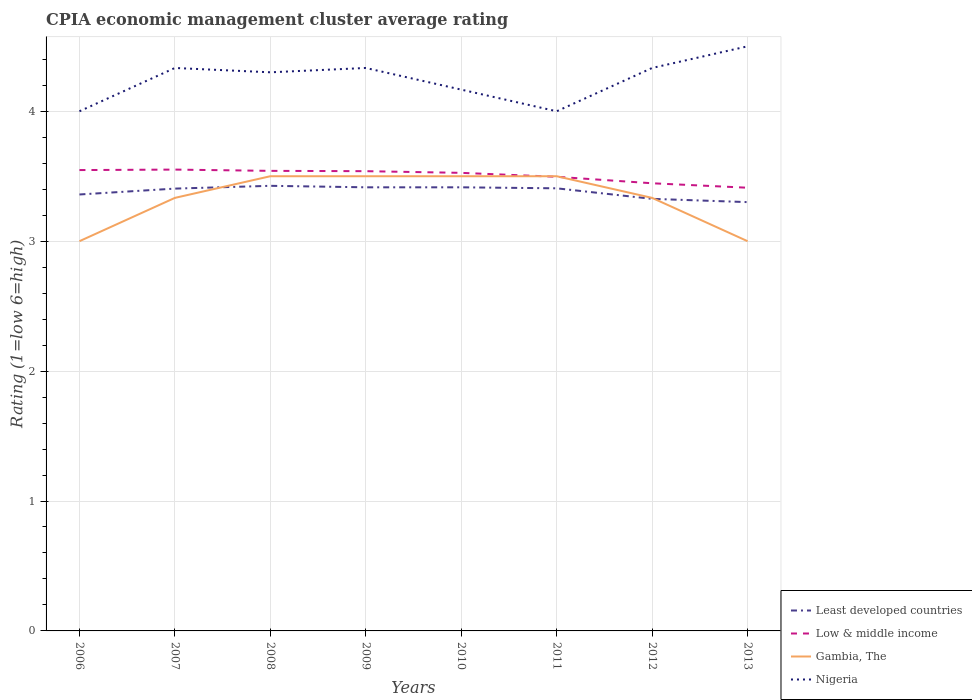How many different coloured lines are there?
Give a very brief answer. 4. Does the line corresponding to Low & middle income intersect with the line corresponding to Least developed countries?
Provide a succinct answer. No. In which year was the CPIA rating in Gambia, The maximum?
Make the answer very short. 2006. What is the total CPIA rating in Gambia, The in the graph?
Your response must be concise. -0.17. What is the difference between the highest and the second highest CPIA rating in Low & middle income?
Make the answer very short. 0.14. What is the difference between the highest and the lowest CPIA rating in Nigeria?
Offer a terse response. 5. Is the CPIA rating in Gambia, The strictly greater than the CPIA rating in Low & middle income over the years?
Your answer should be very brief. No. How many lines are there?
Make the answer very short. 4. What is the difference between two consecutive major ticks on the Y-axis?
Offer a very short reply. 1. How are the legend labels stacked?
Offer a very short reply. Vertical. What is the title of the graph?
Offer a terse response. CPIA economic management cluster average rating. What is the label or title of the Y-axis?
Your answer should be compact. Rating (1=low 6=high). What is the Rating (1=low 6=high) of Least developed countries in 2006?
Make the answer very short. 3.36. What is the Rating (1=low 6=high) of Low & middle income in 2006?
Your answer should be very brief. 3.55. What is the Rating (1=low 6=high) of Least developed countries in 2007?
Keep it short and to the point. 3.4. What is the Rating (1=low 6=high) of Low & middle income in 2007?
Offer a very short reply. 3.55. What is the Rating (1=low 6=high) in Gambia, The in 2007?
Offer a very short reply. 3.33. What is the Rating (1=low 6=high) of Nigeria in 2007?
Ensure brevity in your answer.  4.33. What is the Rating (1=low 6=high) of Least developed countries in 2008?
Provide a succinct answer. 3.43. What is the Rating (1=low 6=high) of Low & middle income in 2008?
Your answer should be compact. 3.54. What is the Rating (1=low 6=high) in Least developed countries in 2009?
Offer a terse response. 3.41. What is the Rating (1=low 6=high) in Low & middle income in 2009?
Ensure brevity in your answer.  3.54. What is the Rating (1=low 6=high) in Gambia, The in 2009?
Offer a terse response. 3.5. What is the Rating (1=low 6=high) of Nigeria in 2009?
Ensure brevity in your answer.  4.33. What is the Rating (1=low 6=high) in Least developed countries in 2010?
Offer a terse response. 3.41. What is the Rating (1=low 6=high) in Low & middle income in 2010?
Offer a terse response. 3.53. What is the Rating (1=low 6=high) of Gambia, The in 2010?
Offer a terse response. 3.5. What is the Rating (1=low 6=high) in Nigeria in 2010?
Offer a terse response. 4.17. What is the Rating (1=low 6=high) in Least developed countries in 2011?
Offer a very short reply. 3.41. What is the Rating (1=low 6=high) in Low & middle income in 2011?
Your answer should be very brief. 3.5. What is the Rating (1=low 6=high) of Least developed countries in 2012?
Offer a very short reply. 3.33. What is the Rating (1=low 6=high) of Low & middle income in 2012?
Give a very brief answer. 3.45. What is the Rating (1=low 6=high) of Gambia, The in 2012?
Make the answer very short. 3.33. What is the Rating (1=low 6=high) of Nigeria in 2012?
Provide a short and direct response. 4.33. What is the Rating (1=low 6=high) in Least developed countries in 2013?
Provide a short and direct response. 3.3. What is the Rating (1=low 6=high) in Low & middle income in 2013?
Offer a terse response. 3.41. Across all years, what is the maximum Rating (1=low 6=high) in Least developed countries?
Provide a short and direct response. 3.43. Across all years, what is the maximum Rating (1=low 6=high) in Low & middle income?
Give a very brief answer. 3.55. Across all years, what is the maximum Rating (1=low 6=high) in Nigeria?
Keep it short and to the point. 4.5. Across all years, what is the minimum Rating (1=low 6=high) of Least developed countries?
Provide a short and direct response. 3.3. Across all years, what is the minimum Rating (1=low 6=high) in Low & middle income?
Make the answer very short. 3.41. What is the total Rating (1=low 6=high) in Least developed countries in the graph?
Your response must be concise. 27.05. What is the total Rating (1=low 6=high) of Low & middle income in the graph?
Ensure brevity in your answer.  28.06. What is the total Rating (1=low 6=high) of Gambia, The in the graph?
Your response must be concise. 26.67. What is the total Rating (1=low 6=high) of Nigeria in the graph?
Offer a terse response. 33.97. What is the difference between the Rating (1=low 6=high) of Least developed countries in 2006 and that in 2007?
Your answer should be very brief. -0.05. What is the difference between the Rating (1=low 6=high) in Low & middle income in 2006 and that in 2007?
Your response must be concise. -0. What is the difference between the Rating (1=low 6=high) in Gambia, The in 2006 and that in 2007?
Your answer should be compact. -0.33. What is the difference between the Rating (1=low 6=high) of Least developed countries in 2006 and that in 2008?
Keep it short and to the point. -0.07. What is the difference between the Rating (1=low 6=high) of Low & middle income in 2006 and that in 2008?
Your response must be concise. 0.01. What is the difference between the Rating (1=low 6=high) in Gambia, The in 2006 and that in 2008?
Give a very brief answer. -0.5. What is the difference between the Rating (1=low 6=high) in Nigeria in 2006 and that in 2008?
Your answer should be very brief. -0.3. What is the difference between the Rating (1=low 6=high) in Least developed countries in 2006 and that in 2009?
Your answer should be compact. -0.06. What is the difference between the Rating (1=low 6=high) in Low & middle income in 2006 and that in 2009?
Keep it short and to the point. 0.01. What is the difference between the Rating (1=low 6=high) of Gambia, The in 2006 and that in 2009?
Ensure brevity in your answer.  -0.5. What is the difference between the Rating (1=low 6=high) of Least developed countries in 2006 and that in 2010?
Provide a short and direct response. -0.06. What is the difference between the Rating (1=low 6=high) in Low & middle income in 2006 and that in 2010?
Offer a terse response. 0.02. What is the difference between the Rating (1=low 6=high) of Gambia, The in 2006 and that in 2010?
Provide a short and direct response. -0.5. What is the difference between the Rating (1=low 6=high) in Nigeria in 2006 and that in 2010?
Provide a short and direct response. -0.17. What is the difference between the Rating (1=low 6=high) of Least developed countries in 2006 and that in 2011?
Offer a terse response. -0.05. What is the difference between the Rating (1=low 6=high) in Low & middle income in 2006 and that in 2011?
Your answer should be compact. 0.05. What is the difference between the Rating (1=low 6=high) in Least developed countries in 2006 and that in 2012?
Give a very brief answer. 0.03. What is the difference between the Rating (1=low 6=high) in Low & middle income in 2006 and that in 2012?
Ensure brevity in your answer.  0.1. What is the difference between the Rating (1=low 6=high) in Gambia, The in 2006 and that in 2012?
Give a very brief answer. -0.33. What is the difference between the Rating (1=low 6=high) in Least developed countries in 2006 and that in 2013?
Your answer should be very brief. 0.06. What is the difference between the Rating (1=low 6=high) in Low & middle income in 2006 and that in 2013?
Your response must be concise. 0.14. What is the difference between the Rating (1=low 6=high) of Nigeria in 2006 and that in 2013?
Provide a short and direct response. -0.5. What is the difference between the Rating (1=low 6=high) of Least developed countries in 2007 and that in 2008?
Keep it short and to the point. -0.02. What is the difference between the Rating (1=low 6=high) of Low & middle income in 2007 and that in 2008?
Make the answer very short. 0.01. What is the difference between the Rating (1=low 6=high) of Nigeria in 2007 and that in 2008?
Offer a very short reply. 0.03. What is the difference between the Rating (1=low 6=high) in Least developed countries in 2007 and that in 2009?
Offer a very short reply. -0.01. What is the difference between the Rating (1=low 6=high) in Low & middle income in 2007 and that in 2009?
Ensure brevity in your answer.  0.01. What is the difference between the Rating (1=low 6=high) in Gambia, The in 2007 and that in 2009?
Your response must be concise. -0.17. What is the difference between the Rating (1=low 6=high) in Least developed countries in 2007 and that in 2010?
Make the answer very short. -0.01. What is the difference between the Rating (1=low 6=high) of Low & middle income in 2007 and that in 2010?
Your answer should be compact. 0.03. What is the difference between the Rating (1=low 6=high) in Nigeria in 2007 and that in 2010?
Offer a terse response. 0.17. What is the difference between the Rating (1=low 6=high) in Least developed countries in 2007 and that in 2011?
Make the answer very short. -0. What is the difference between the Rating (1=low 6=high) in Low & middle income in 2007 and that in 2011?
Offer a very short reply. 0.06. What is the difference between the Rating (1=low 6=high) of Gambia, The in 2007 and that in 2011?
Your answer should be compact. -0.17. What is the difference between the Rating (1=low 6=high) of Nigeria in 2007 and that in 2011?
Your answer should be very brief. 0.33. What is the difference between the Rating (1=low 6=high) of Least developed countries in 2007 and that in 2012?
Offer a terse response. 0.08. What is the difference between the Rating (1=low 6=high) in Low & middle income in 2007 and that in 2012?
Make the answer very short. 0.11. What is the difference between the Rating (1=low 6=high) in Nigeria in 2007 and that in 2012?
Provide a short and direct response. 0. What is the difference between the Rating (1=low 6=high) in Least developed countries in 2007 and that in 2013?
Ensure brevity in your answer.  0.1. What is the difference between the Rating (1=low 6=high) in Low & middle income in 2007 and that in 2013?
Your answer should be very brief. 0.14. What is the difference between the Rating (1=low 6=high) of Least developed countries in 2008 and that in 2009?
Provide a short and direct response. 0.01. What is the difference between the Rating (1=low 6=high) in Low & middle income in 2008 and that in 2009?
Offer a very short reply. 0. What is the difference between the Rating (1=low 6=high) of Gambia, The in 2008 and that in 2009?
Offer a terse response. 0. What is the difference between the Rating (1=low 6=high) in Nigeria in 2008 and that in 2009?
Your answer should be very brief. -0.03. What is the difference between the Rating (1=low 6=high) of Least developed countries in 2008 and that in 2010?
Ensure brevity in your answer.  0.01. What is the difference between the Rating (1=low 6=high) of Low & middle income in 2008 and that in 2010?
Make the answer very short. 0.02. What is the difference between the Rating (1=low 6=high) of Nigeria in 2008 and that in 2010?
Your response must be concise. 0.13. What is the difference between the Rating (1=low 6=high) of Least developed countries in 2008 and that in 2011?
Provide a succinct answer. 0.02. What is the difference between the Rating (1=low 6=high) of Low & middle income in 2008 and that in 2011?
Provide a succinct answer. 0.05. What is the difference between the Rating (1=low 6=high) of Nigeria in 2008 and that in 2011?
Your answer should be very brief. 0.3. What is the difference between the Rating (1=low 6=high) of Least developed countries in 2008 and that in 2012?
Your response must be concise. 0.1. What is the difference between the Rating (1=low 6=high) in Low & middle income in 2008 and that in 2012?
Your answer should be compact. 0.1. What is the difference between the Rating (1=low 6=high) in Nigeria in 2008 and that in 2012?
Your answer should be very brief. -0.03. What is the difference between the Rating (1=low 6=high) in Least developed countries in 2008 and that in 2013?
Give a very brief answer. 0.13. What is the difference between the Rating (1=low 6=high) of Low & middle income in 2008 and that in 2013?
Your response must be concise. 0.13. What is the difference between the Rating (1=low 6=high) of Gambia, The in 2008 and that in 2013?
Offer a very short reply. 0.5. What is the difference between the Rating (1=low 6=high) of Nigeria in 2008 and that in 2013?
Provide a succinct answer. -0.2. What is the difference between the Rating (1=low 6=high) in Least developed countries in 2009 and that in 2010?
Your response must be concise. 0. What is the difference between the Rating (1=low 6=high) of Low & middle income in 2009 and that in 2010?
Make the answer very short. 0.01. What is the difference between the Rating (1=low 6=high) in Nigeria in 2009 and that in 2010?
Offer a very short reply. 0.17. What is the difference between the Rating (1=low 6=high) in Least developed countries in 2009 and that in 2011?
Make the answer very short. 0.01. What is the difference between the Rating (1=low 6=high) of Low & middle income in 2009 and that in 2011?
Ensure brevity in your answer.  0.04. What is the difference between the Rating (1=low 6=high) of Nigeria in 2009 and that in 2011?
Offer a very short reply. 0.33. What is the difference between the Rating (1=low 6=high) of Least developed countries in 2009 and that in 2012?
Make the answer very short. 0.09. What is the difference between the Rating (1=low 6=high) in Low & middle income in 2009 and that in 2012?
Ensure brevity in your answer.  0.09. What is the difference between the Rating (1=low 6=high) of Gambia, The in 2009 and that in 2012?
Your response must be concise. 0.17. What is the difference between the Rating (1=low 6=high) in Least developed countries in 2009 and that in 2013?
Provide a succinct answer. 0.11. What is the difference between the Rating (1=low 6=high) in Low & middle income in 2009 and that in 2013?
Keep it short and to the point. 0.13. What is the difference between the Rating (1=low 6=high) in Gambia, The in 2009 and that in 2013?
Your answer should be compact. 0.5. What is the difference between the Rating (1=low 6=high) of Nigeria in 2009 and that in 2013?
Keep it short and to the point. -0.17. What is the difference between the Rating (1=low 6=high) of Least developed countries in 2010 and that in 2011?
Your response must be concise. 0.01. What is the difference between the Rating (1=low 6=high) of Low & middle income in 2010 and that in 2011?
Ensure brevity in your answer.  0.03. What is the difference between the Rating (1=low 6=high) of Least developed countries in 2010 and that in 2012?
Give a very brief answer. 0.09. What is the difference between the Rating (1=low 6=high) in Low & middle income in 2010 and that in 2012?
Keep it short and to the point. 0.08. What is the difference between the Rating (1=low 6=high) in Gambia, The in 2010 and that in 2012?
Offer a terse response. 0.17. What is the difference between the Rating (1=low 6=high) in Least developed countries in 2010 and that in 2013?
Your answer should be compact. 0.11. What is the difference between the Rating (1=low 6=high) in Low & middle income in 2010 and that in 2013?
Make the answer very short. 0.11. What is the difference between the Rating (1=low 6=high) of Nigeria in 2010 and that in 2013?
Your answer should be very brief. -0.33. What is the difference between the Rating (1=low 6=high) in Least developed countries in 2011 and that in 2012?
Provide a short and direct response. 0.08. What is the difference between the Rating (1=low 6=high) of Low & middle income in 2011 and that in 2012?
Your answer should be compact. 0.05. What is the difference between the Rating (1=low 6=high) of Nigeria in 2011 and that in 2012?
Ensure brevity in your answer.  -0.33. What is the difference between the Rating (1=low 6=high) of Least developed countries in 2011 and that in 2013?
Your answer should be very brief. 0.11. What is the difference between the Rating (1=low 6=high) in Low & middle income in 2011 and that in 2013?
Provide a succinct answer. 0.08. What is the difference between the Rating (1=low 6=high) of Gambia, The in 2011 and that in 2013?
Keep it short and to the point. 0.5. What is the difference between the Rating (1=low 6=high) in Nigeria in 2011 and that in 2013?
Provide a short and direct response. -0.5. What is the difference between the Rating (1=low 6=high) in Least developed countries in 2012 and that in 2013?
Ensure brevity in your answer.  0.03. What is the difference between the Rating (1=low 6=high) in Low & middle income in 2012 and that in 2013?
Ensure brevity in your answer.  0.03. What is the difference between the Rating (1=low 6=high) in Nigeria in 2012 and that in 2013?
Provide a succinct answer. -0.17. What is the difference between the Rating (1=low 6=high) in Least developed countries in 2006 and the Rating (1=low 6=high) in Low & middle income in 2007?
Provide a succinct answer. -0.19. What is the difference between the Rating (1=low 6=high) of Least developed countries in 2006 and the Rating (1=low 6=high) of Gambia, The in 2007?
Your answer should be compact. 0.03. What is the difference between the Rating (1=low 6=high) in Least developed countries in 2006 and the Rating (1=low 6=high) in Nigeria in 2007?
Keep it short and to the point. -0.97. What is the difference between the Rating (1=low 6=high) in Low & middle income in 2006 and the Rating (1=low 6=high) in Gambia, The in 2007?
Provide a short and direct response. 0.21. What is the difference between the Rating (1=low 6=high) of Low & middle income in 2006 and the Rating (1=low 6=high) of Nigeria in 2007?
Provide a short and direct response. -0.79. What is the difference between the Rating (1=low 6=high) in Gambia, The in 2006 and the Rating (1=low 6=high) in Nigeria in 2007?
Ensure brevity in your answer.  -1.33. What is the difference between the Rating (1=low 6=high) in Least developed countries in 2006 and the Rating (1=low 6=high) in Low & middle income in 2008?
Your response must be concise. -0.18. What is the difference between the Rating (1=low 6=high) in Least developed countries in 2006 and the Rating (1=low 6=high) in Gambia, The in 2008?
Offer a terse response. -0.14. What is the difference between the Rating (1=low 6=high) of Least developed countries in 2006 and the Rating (1=low 6=high) of Nigeria in 2008?
Provide a succinct answer. -0.94. What is the difference between the Rating (1=low 6=high) of Low & middle income in 2006 and the Rating (1=low 6=high) of Gambia, The in 2008?
Give a very brief answer. 0.05. What is the difference between the Rating (1=low 6=high) of Low & middle income in 2006 and the Rating (1=low 6=high) of Nigeria in 2008?
Offer a terse response. -0.75. What is the difference between the Rating (1=low 6=high) in Gambia, The in 2006 and the Rating (1=low 6=high) in Nigeria in 2008?
Your response must be concise. -1.3. What is the difference between the Rating (1=low 6=high) of Least developed countries in 2006 and the Rating (1=low 6=high) of Low & middle income in 2009?
Ensure brevity in your answer.  -0.18. What is the difference between the Rating (1=low 6=high) in Least developed countries in 2006 and the Rating (1=low 6=high) in Gambia, The in 2009?
Make the answer very short. -0.14. What is the difference between the Rating (1=low 6=high) of Least developed countries in 2006 and the Rating (1=low 6=high) of Nigeria in 2009?
Offer a very short reply. -0.97. What is the difference between the Rating (1=low 6=high) in Low & middle income in 2006 and the Rating (1=low 6=high) in Gambia, The in 2009?
Offer a very short reply. 0.05. What is the difference between the Rating (1=low 6=high) of Low & middle income in 2006 and the Rating (1=low 6=high) of Nigeria in 2009?
Offer a terse response. -0.79. What is the difference between the Rating (1=low 6=high) in Gambia, The in 2006 and the Rating (1=low 6=high) in Nigeria in 2009?
Provide a short and direct response. -1.33. What is the difference between the Rating (1=low 6=high) of Least developed countries in 2006 and the Rating (1=low 6=high) of Low & middle income in 2010?
Offer a terse response. -0.17. What is the difference between the Rating (1=low 6=high) of Least developed countries in 2006 and the Rating (1=low 6=high) of Gambia, The in 2010?
Provide a succinct answer. -0.14. What is the difference between the Rating (1=low 6=high) of Least developed countries in 2006 and the Rating (1=low 6=high) of Nigeria in 2010?
Provide a short and direct response. -0.81. What is the difference between the Rating (1=low 6=high) in Low & middle income in 2006 and the Rating (1=low 6=high) in Gambia, The in 2010?
Your answer should be very brief. 0.05. What is the difference between the Rating (1=low 6=high) in Low & middle income in 2006 and the Rating (1=low 6=high) in Nigeria in 2010?
Offer a very short reply. -0.62. What is the difference between the Rating (1=low 6=high) of Gambia, The in 2006 and the Rating (1=low 6=high) of Nigeria in 2010?
Give a very brief answer. -1.17. What is the difference between the Rating (1=low 6=high) of Least developed countries in 2006 and the Rating (1=low 6=high) of Low & middle income in 2011?
Your response must be concise. -0.14. What is the difference between the Rating (1=low 6=high) of Least developed countries in 2006 and the Rating (1=low 6=high) of Gambia, The in 2011?
Ensure brevity in your answer.  -0.14. What is the difference between the Rating (1=low 6=high) in Least developed countries in 2006 and the Rating (1=low 6=high) in Nigeria in 2011?
Your answer should be very brief. -0.64. What is the difference between the Rating (1=low 6=high) of Low & middle income in 2006 and the Rating (1=low 6=high) of Gambia, The in 2011?
Provide a succinct answer. 0.05. What is the difference between the Rating (1=low 6=high) in Low & middle income in 2006 and the Rating (1=low 6=high) in Nigeria in 2011?
Ensure brevity in your answer.  -0.45. What is the difference between the Rating (1=low 6=high) in Gambia, The in 2006 and the Rating (1=low 6=high) in Nigeria in 2011?
Give a very brief answer. -1. What is the difference between the Rating (1=low 6=high) in Least developed countries in 2006 and the Rating (1=low 6=high) in Low & middle income in 2012?
Your response must be concise. -0.09. What is the difference between the Rating (1=low 6=high) in Least developed countries in 2006 and the Rating (1=low 6=high) in Gambia, The in 2012?
Your answer should be compact. 0.03. What is the difference between the Rating (1=low 6=high) of Least developed countries in 2006 and the Rating (1=low 6=high) of Nigeria in 2012?
Your answer should be very brief. -0.97. What is the difference between the Rating (1=low 6=high) of Low & middle income in 2006 and the Rating (1=low 6=high) of Gambia, The in 2012?
Your answer should be very brief. 0.21. What is the difference between the Rating (1=low 6=high) of Low & middle income in 2006 and the Rating (1=low 6=high) of Nigeria in 2012?
Give a very brief answer. -0.79. What is the difference between the Rating (1=low 6=high) of Gambia, The in 2006 and the Rating (1=low 6=high) of Nigeria in 2012?
Your answer should be very brief. -1.33. What is the difference between the Rating (1=low 6=high) of Least developed countries in 2006 and the Rating (1=low 6=high) of Low & middle income in 2013?
Your response must be concise. -0.05. What is the difference between the Rating (1=low 6=high) in Least developed countries in 2006 and the Rating (1=low 6=high) in Gambia, The in 2013?
Provide a short and direct response. 0.36. What is the difference between the Rating (1=low 6=high) in Least developed countries in 2006 and the Rating (1=low 6=high) in Nigeria in 2013?
Ensure brevity in your answer.  -1.14. What is the difference between the Rating (1=low 6=high) of Low & middle income in 2006 and the Rating (1=low 6=high) of Gambia, The in 2013?
Offer a terse response. 0.55. What is the difference between the Rating (1=low 6=high) in Low & middle income in 2006 and the Rating (1=low 6=high) in Nigeria in 2013?
Provide a short and direct response. -0.95. What is the difference between the Rating (1=low 6=high) of Least developed countries in 2007 and the Rating (1=low 6=high) of Low & middle income in 2008?
Give a very brief answer. -0.14. What is the difference between the Rating (1=low 6=high) in Least developed countries in 2007 and the Rating (1=low 6=high) in Gambia, The in 2008?
Provide a short and direct response. -0.1. What is the difference between the Rating (1=low 6=high) in Least developed countries in 2007 and the Rating (1=low 6=high) in Nigeria in 2008?
Give a very brief answer. -0.9. What is the difference between the Rating (1=low 6=high) in Low & middle income in 2007 and the Rating (1=low 6=high) in Gambia, The in 2008?
Give a very brief answer. 0.05. What is the difference between the Rating (1=low 6=high) in Low & middle income in 2007 and the Rating (1=low 6=high) in Nigeria in 2008?
Ensure brevity in your answer.  -0.75. What is the difference between the Rating (1=low 6=high) of Gambia, The in 2007 and the Rating (1=low 6=high) of Nigeria in 2008?
Give a very brief answer. -0.97. What is the difference between the Rating (1=low 6=high) in Least developed countries in 2007 and the Rating (1=low 6=high) in Low & middle income in 2009?
Offer a very short reply. -0.13. What is the difference between the Rating (1=low 6=high) of Least developed countries in 2007 and the Rating (1=low 6=high) of Gambia, The in 2009?
Give a very brief answer. -0.1. What is the difference between the Rating (1=low 6=high) in Least developed countries in 2007 and the Rating (1=low 6=high) in Nigeria in 2009?
Ensure brevity in your answer.  -0.93. What is the difference between the Rating (1=low 6=high) of Low & middle income in 2007 and the Rating (1=low 6=high) of Gambia, The in 2009?
Keep it short and to the point. 0.05. What is the difference between the Rating (1=low 6=high) in Low & middle income in 2007 and the Rating (1=low 6=high) in Nigeria in 2009?
Keep it short and to the point. -0.78. What is the difference between the Rating (1=low 6=high) in Least developed countries in 2007 and the Rating (1=low 6=high) in Low & middle income in 2010?
Provide a succinct answer. -0.12. What is the difference between the Rating (1=low 6=high) in Least developed countries in 2007 and the Rating (1=low 6=high) in Gambia, The in 2010?
Offer a terse response. -0.1. What is the difference between the Rating (1=low 6=high) in Least developed countries in 2007 and the Rating (1=low 6=high) in Nigeria in 2010?
Give a very brief answer. -0.76. What is the difference between the Rating (1=low 6=high) of Low & middle income in 2007 and the Rating (1=low 6=high) of Gambia, The in 2010?
Ensure brevity in your answer.  0.05. What is the difference between the Rating (1=low 6=high) in Low & middle income in 2007 and the Rating (1=low 6=high) in Nigeria in 2010?
Your answer should be compact. -0.62. What is the difference between the Rating (1=low 6=high) of Gambia, The in 2007 and the Rating (1=low 6=high) of Nigeria in 2010?
Offer a terse response. -0.83. What is the difference between the Rating (1=low 6=high) of Least developed countries in 2007 and the Rating (1=low 6=high) of Low & middle income in 2011?
Offer a terse response. -0.09. What is the difference between the Rating (1=low 6=high) in Least developed countries in 2007 and the Rating (1=low 6=high) in Gambia, The in 2011?
Offer a terse response. -0.1. What is the difference between the Rating (1=low 6=high) in Least developed countries in 2007 and the Rating (1=low 6=high) in Nigeria in 2011?
Make the answer very short. -0.6. What is the difference between the Rating (1=low 6=high) of Low & middle income in 2007 and the Rating (1=low 6=high) of Gambia, The in 2011?
Provide a short and direct response. 0.05. What is the difference between the Rating (1=low 6=high) of Low & middle income in 2007 and the Rating (1=low 6=high) of Nigeria in 2011?
Give a very brief answer. -0.45. What is the difference between the Rating (1=low 6=high) in Least developed countries in 2007 and the Rating (1=low 6=high) in Low & middle income in 2012?
Your answer should be very brief. -0.04. What is the difference between the Rating (1=low 6=high) of Least developed countries in 2007 and the Rating (1=low 6=high) of Gambia, The in 2012?
Make the answer very short. 0.07. What is the difference between the Rating (1=low 6=high) in Least developed countries in 2007 and the Rating (1=low 6=high) in Nigeria in 2012?
Your response must be concise. -0.93. What is the difference between the Rating (1=low 6=high) in Low & middle income in 2007 and the Rating (1=low 6=high) in Gambia, The in 2012?
Make the answer very short. 0.22. What is the difference between the Rating (1=low 6=high) in Low & middle income in 2007 and the Rating (1=low 6=high) in Nigeria in 2012?
Keep it short and to the point. -0.78. What is the difference between the Rating (1=low 6=high) of Least developed countries in 2007 and the Rating (1=low 6=high) of Low & middle income in 2013?
Your answer should be very brief. -0.01. What is the difference between the Rating (1=low 6=high) in Least developed countries in 2007 and the Rating (1=low 6=high) in Gambia, The in 2013?
Your answer should be very brief. 0.4. What is the difference between the Rating (1=low 6=high) in Least developed countries in 2007 and the Rating (1=low 6=high) in Nigeria in 2013?
Keep it short and to the point. -1.1. What is the difference between the Rating (1=low 6=high) in Low & middle income in 2007 and the Rating (1=low 6=high) in Gambia, The in 2013?
Keep it short and to the point. 0.55. What is the difference between the Rating (1=low 6=high) in Low & middle income in 2007 and the Rating (1=low 6=high) in Nigeria in 2013?
Keep it short and to the point. -0.95. What is the difference between the Rating (1=low 6=high) in Gambia, The in 2007 and the Rating (1=low 6=high) in Nigeria in 2013?
Your answer should be very brief. -1.17. What is the difference between the Rating (1=low 6=high) of Least developed countries in 2008 and the Rating (1=low 6=high) of Low & middle income in 2009?
Your response must be concise. -0.11. What is the difference between the Rating (1=low 6=high) of Least developed countries in 2008 and the Rating (1=low 6=high) of Gambia, The in 2009?
Ensure brevity in your answer.  -0.07. What is the difference between the Rating (1=low 6=high) in Least developed countries in 2008 and the Rating (1=low 6=high) in Nigeria in 2009?
Provide a short and direct response. -0.91. What is the difference between the Rating (1=low 6=high) in Low & middle income in 2008 and the Rating (1=low 6=high) in Gambia, The in 2009?
Offer a very short reply. 0.04. What is the difference between the Rating (1=low 6=high) of Low & middle income in 2008 and the Rating (1=low 6=high) of Nigeria in 2009?
Make the answer very short. -0.79. What is the difference between the Rating (1=low 6=high) of Gambia, The in 2008 and the Rating (1=low 6=high) of Nigeria in 2009?
Make the answer very short. -0.83. What is the difference between the Rating (1=low 6=high) of Least developed countries in 2008 and the Rating (1=low 6=high) of Low & middle income in 2010?
Your answer should be very brief. -0.1. What is the difference between the Rating (1=low 6=high) in Least developed countries in 2008 and the Rating (1=low 6=high) in Gambia, The in 2010?
Keep it short and to the point. -0.07. What is the difference between the Rating (1=low 6=high) in Least developed countries in 2008 and the Rating (1=low 6=high) in Nigeria in 2010?
Keep it short and to the point. -0.74. What is the difference between the Rating (1=low 6=high) of Low & middle income in 2008 and the Rating (1=low 6=high) of Gambia, The in 2010?
Your answer should be compact. 0.04. What is the difference between the Rating (1=low 6=high) of Low & middle income in 2008 and the Rating (1=low 6=high) of Nigeria in 2010?
Provide a short and direct response. -0.63. What is the difference between the Rating (1=low 6=high) in Least developed countries in 2008 and the Rating (1=low 6=high) in Low & middle income in 2011?
Make the answer very short. -0.07. What is the difference between the Rating (1=low 6=high) of Least developed countries in 2008 and the Rating (1=low 6=high) of Gambia, The in 2011?
Give a very brief answer. -0.07. What is the difference between the Rating (1=low 6=high) of Least developed countries in 2008 and the Rating (1=low 6=high) of Nigeria in 2011?
Provide a short and direct response. -0.57. What is the difference between the Rating (1=low 6=high) of Low & middle income in 2008 and the Rating (1=low 6=high) of Gambia, The in 2011?
Make the answer very short. 0.04. What is the difference between the Rating (1=low 6=high) of Low & middle income in 2008 and the Rating (1=low 6=high) of Nigeria in 2011?
Give a very brief answer. -0.46. What is the difference between the Rating (1=low 6=high) in Least developed countries in 2008 and the Rating (1=low 6=high) in Low & middle income in 2012?
Your response must be concise. -0.02. What is the difference between the Rating (1=low 6=high) of Least developed countries in 2008 and the Rating (1=low 6=high) of Gambia, The in 2012?
Make the answer very short. 0.09. What is the difference between the Rating (1=low 6=high) of Least developed countries in 2008 and the Rating (1=low 6=high) of Nigeria in 2012?
Your answer should be very brief. -0.91. What is the difference between the Rating (1=low 6=high) of Low & middle income in 2008 and the Rating (1=low 6=high) of Gambia, The in 2012?
Your response must be concise. 0.21. What is the difference between the Rating (1=low 6=high) of Low & middle income in 2008 and the Rating (1=low 6=high) of Nigeria in 2012?
Give a very brief answer. -0.79. What is the difference between the Rating (1=low 6=high) in Least developed countries in 2008 and the Rating (1=low 6=high) in Low & middle income in 2013?
Ensure brevity in your answer.  0.01. What is the difference between the Rating (1=low 6=high) of Least developed countries in 2008 and the Rating (1=low 6=high) of Gambia, The in 2013?
Provide a succinct answer. 0.43. What is the difference between the Rating (1=low 6=high) in Least developed countries in 2008 and the Rating (1=low 6=high) in Nigeria in 2013?
Provide a succinct answer. -1.07. What is the difference between the Rating (1=low 6=high) of Low & middle income in 2008 and the Rating (1=low 6=high) of Gambia, The in 2013?
Make the answer very short. 0.54. What is the difference between the Rating (1=low 6=high) in Low & middle income in 2008 and the Rating (1=low 6=high) in Nigeria in 2013?
Keep it short and to the point. -0.96. What is the difference between the Rating (1=low 6=high) in Least developed countries in 2009 and the Rating (1=low 6=high) in Low & middle income in 2010?
Your response must be concise. -0.11. What is the difference between the Rating (1=low 6=high) in Least developed countries in 2009 and the Rating (1=low 6=high) in Gambia, The in 2010?
Give a very brief answer. -0.09. What is the difference between the Rating (1=low 6=high) of Least developed countries in 2009 and the Rating (1=low 6=high) of Nigeria in 2010?
Give a very brief answer. -0.75. What is the difference between the Rating (1=low 6=high) in Low & middle income in 2009 and the Rating (1=low 6=high) in Gambia, The in 2010?
Your answer should be compact. 0.04. What is the difference between the Rating (1=low 6=high) of Low & middle income in 2009 and the Rating (1=low 6=high) of Nigeria in 2010?
Your answer should be very brief. -0.63. What is the difference between the Rating (1=low 6=high) in Least developed countries in 2009 and the Rating (1=low 6=high) in Low & middle income in 2011?
Your response must be concise. -0.08. What is the difference between the Rating (1=low 6=high) of Least developed countries in 2009 and the Rating (1=low 6=high) of Gambia, The in 2011?
Offer a terse response. -0.09. What is the difference between the Rating (1=low 6=high) of Least developed countries in 2009 and the Rating (1=low 6=high) of Nigeria in 2011?
Keep it short and to the point. -0.59. What is the difference between the Rating (1=low 6=high) in Low & middle income in 2009 and the Rating (1=low 6=high) in Gambia, The in 2011?
Offer a very short reply. 0.04. What is the difference between the Rating (1=low 6=high) in Low & middle income in 2009 and the Rating (1=low 6=high) in Nigeria in 2011?
Give a very brief answer. -0.46. What is the difference between the Rating (1=low 6=high) in Gambia, The in 2009 and the Rating (1=low 6=high) in Nigeria in 2011?
Ensure brevity in your answer.  -0.5. What is the difference between the Rating (1=low 6=high) in Least developed countries in 2009 and the Rating (1=low 6=high) in Low & middle income in 2012?
Your answer should be compact. -0.03. What is the difference between the Rating (1=low 6=high) of Least developed countries in 2009 and the Rating (1=low 6=high) of Gambia, The in 2012?
Ensure brevity in your answer.  0.08. What is the difference between the Rating (1=low 6=high) in Least developed countries in 2009 and the Rating (1=low 6=high) in Nigeria in 2012?
Your answer should be very brief. -0.92. What is the difference between the Rating (1=low 6=high) in Low & middle income in 2009 and the Rating (1=low 6=high) in Gambia, The in 2012?
Make the answer very short. 0.21. What is the difference between the Rating (1=low 6=high) in Low & middle income in 2009 and the Rating (1=low 6=high) in Nigeria in 2012?
Give a very brief answer. -0.79. What is the difference between the Rating (1=low 6=high) in Gambia, The in 2009 and the Rating (1=low 6=high) in Nigeria in 2012?
Ensure brevity in your answer.  -0.83. What is the difference between the Rating (1=low 6=high) in Least developed countries in 2009 and the Rating (1=low 6=high) in Low & middle income in 2013?
Ensure brevity in your answer.  0. What is the difference between the Rating (1=low 6=high) in Least developed countries in 2009 and the Rating (1=low 6=high) in Gambia, The in 2013?
Offer a terse response. 0.41. What is the difference between the Rating (1=low 6=high) of Least developed countries in 2009 and the Rating (1=low 6=high) of Nigeria in 2013?
Your answer should be very brief. -1.09. What is the difference between the Rating (1=low 6=high) of Low & middle income in 2009 and the Rating (1=low 6=high) of Gambia, The in 2013?
Give a very brief answer. 0.54. What is the difference between the Rating (1=low 6=high) of Low & middle income in 2009 and the Rating (1=low 6=high) of Nigeria in 2013?
Keep it short and to the point. -0.96. What is the difference between the Rating (1=low 6=high) in Least developed countries in 2010 and the Rating (1=low 6=high) in Low & middle income in 2011?
Make the answer very short. -0.08. What is the difference between the Rating (1=low 6=high) of Least developed countries in 2010 and the Rating (1=low 6=high) of Gambia, The in 2011?
Keep it short and to the point. -0.09. What is the difference between the Rating (1=low 6=high) of Least developed countries in 2010 and the Rating (1=low 6=high) of Nigeria in 2011?
Your answer should be very brief. -0.59. What is the difference between the Rating (1=low 6=high) in Low & middle income in 2010 and the Rating (1=low 6=high) in Gambia, The in 2011?
Your answer should be compact. 0.03. What is the difference between the Rating (1=low 6=high) in Low & middle income in 2010 and the Rating (1=low 6=high) in Nigeria in 2011?
Keep it short and to the point. -0.47. What is the difference between the Rating (1=low 6=high) in Least developed countries in 2010 and the Rating (1=low 6=high) in Low & middle income in 2012?
Your answer should be very brief. -0.03. What is the difference between the Rating (1=low 6=high) in Least developed countries in 2010 and the Rating (1=low 6=high) in Gambia, The in 2012?
Give a very brief answer. 0.08. What is the difference between the Rating (1=low 6=high) of Least developed countries in 2010 and the Rating (1=low 6=high) of Nigeria in 2012?
Offer a very short reply. -0.92. What is the difference between the Rating (1=low 6=high) in Low & middle income in 2010 and the Rating (1=low 6=high) in Gambia, The in 2012?
Offer a very short reply. 0.19. What is the difference between the Rating (1=low 6=high) in Low & middle income in 2010 and the Rating (1=low 6=high) in Nigeria in 2012?
Give a very brief answer. -0.81. What is the difference between the Rating (1=low 6=high) of Least developed countries in 2010 and the Rating (1=low 6=high) of Low & middle income in 2013?
Your answer should be compact. 0. What is the difference between the Rating (1=low 6=high) in Least developed countries in 2010 and the Rating (1=low 6=high) in Gambia, The in 2013?
Keep it short and to the point. 0.41. What is the difference between the Rating (1=low 6=high) in Least developed countries in 2010 and the Rating (1=low 6=high) in Nigeria in 2013?
Make the answer very short. -1.09. What is the difference between the Rating (1=low 6=high) in Low & middle income in 2010 and the Rating (1=low 6=high) in Gambia, The in 2013?
Your answer should be compact. 0.53. What is the difference between the Rating (1=low 6=high) in Low & middle income in 2010 and the Rating (1=low 6=high) in Nigeria in 2013?
Provide a succinct answer. -0.97. What is the difference between the Rating (1=low 6=high) of Least developed countries in 2011 and the Rating (1=low 6=high) of Low & middle income in 2012?
Make the answer very short. -0.04. What is the difference between the Rating (1=low 6=high) of Least developed countries in 2011 and the Rating (1=low 6=high) of Gambia, The in 2012?
Give a very brief answer. 0.07. What is the difference between the Rating (1=low 6=high) of Least developed countries in 2011 and the Rating (1=low 6=high) of Nigeria in 2012?
Offer a terse response. -0.93. What is the difference between the Rating (1=low 6=high) of Low & middle income in 2011 and the Rating (1=low 6=high) of Gambia, The in 2012?
Ensure brevity in your answer.  0.16. What is the difference between the Rating (1=low 6=high) in Low & middle income in 2011 and the Rating (1=low 6=high) in Nigeria in 2012?
Give a very brief answer. -0.84. What is the difference between the Rating (1=low 6=high) of Least developed countries in 2011 and the Rating (1=low 6=high) of Low & middle income in 2013?
Offer a terse response. -0. What is the difference between the Rating (1=low 6=high) of Least developed countries in 2011 and the Rating (1=low 6=high) of Gambia, The in 2013?
Your answer should be very brief. 0.41. What is the difference between the Rating (1=low 6=high) of Least developed countries in 2011 and the Rating (1=low 6=high) of Nigeria in 2013?
Make the answer very short. -1.09. What is the difference between the Rating (1=low 6=high) in Low & middle income in 2011 and the Rating (1=low 6=high) in Gambia, The in 2013?
Your answer should be compact. 0.5. What is the difference between the Rating (1=low 6=high) in Low & middle income in 2011 and the Rating (1=low 6=high) in Nigeria in 2013?
Offer a very short reply. -1. What is the difference between the Rating (1=low 6=high) of Gambia, The in 2011 and the Rating (1=low 6=high) of Nigeria in 2013?
Ensure brevity in your answer.  -1. What is the difference between the Rating (1=low 6=high) of Least developed countries in 2012 and the Rating (1=low 6=high) of Low & middle income in 2013?
Give a very brief answer. -0.09. What is the difference between the Rating (1=low 6=high) of Least developed countries in 2012 and the Rating (1=low 6=high) of Gambia, The in 2013?
Give a very brief answer. 0.33. What is the difference between the Rating (1=low 6=high) of Least developed countries in 2012 and the Rating (1=low 6=high) of Nigeria in 2013?
Your answer should be very brief. -1.17. What is the difference between the Rating (1=low 6=high) of Low & middle income in 2012 and the Rating (1=low 6=high) of Gambia, The in 2013?
Make the answer very short. 0.45. What is the difference between the Rating (1=low 6=high) of Low & middle income in 2012 and the Rating (1=low 6=high) of Nigeria in 2013?
Keep it short and to the point. -1.05. What is the difference between the Rating (1=low 6=high) in Gambia, The in 2012 and the Rating (1=low 6=high) in Nigeria in 2013?
Provide a succinct answer. -1.17. What is the average Rating (1=low 6=high) of Least developed countries per year?
Offer a very short reply. 3.38. What is the average Rating (1=low 6=high) in Low & middle income per year?
Provide a succinct answer. 3.51. What is the average Rating (1=low 6=high) of Gambia, The per year?
Offer a very short reply. 3.33. What is the average Rating (1=low 6=high) in Nigeria per year?
Give a very brief answer. 4.25. In the year 2006, what is the difference between the Rating (1=low 6=high) of Least developed countries and Rating (1=low 6=high) of Low & middle income?
Offer a terse response. -0.19. In the year 2006, what is the difference between the Rating (1=low 6=high) in Least developed countries and Rating (1=low 6=high) in Gambia, The?
Offer a terse response. 0.36. In the year 2006, what is the difference between the Rating (1=low 6=high) of Least developed countries and Rating (1=low 6=high) of Nigeria?
Provide a succinct answer. -0.64. In the year 2006, what is the difference between the Rating (1=low 6=high) of Low & middle income and Rating (1=low 6=high) of Gambia, The?
Make the answer very short. 0.55. In the year 2006, what is the difference between the Rating (1=low 6=high) in Low & middle income and Rating (1=low 6=high) in Nigeria?
Provide a succinct answer. -0.45. In the year 2007, what is the difference between the Rating (1=low 6=high) in Least developed countries and Rating (1=low 6=high) in Low & middle income?
Offer a terse response. -0.15. In the year 2007, what is the difference between the Rating (1=low 6=high) in Least developed countries and Rating (1=low 6=high) in Gambia, The?
Give a very brief answer. 0.07. In the year 2007, what is the difference between the Rating (1=low 6=high) in Least developed countries and Rating (1=low 6=high) in Nigeria?
Ensure brevity in your answer.  -0.93. In the year 2007, what is the difference between the Rating (1=low 6=high) in Low & middle income and Rating (1=low 6=high) in Gambia, The?
Provide a succinct answer. 0.22. In the year 2007, what is the difference between the Rating (1=low 6=high) in Low & middle income and Rating (1=low 6=high) in Nigeria?
Your answer should be compact. -0.78. In the year 2007, what is the difference between the Rating (1=low 6=high) in Gambia, The and Rating (1=low 6=high) in Nigeria?
Offer a very short reply. -1. In the year 2008, what is the difference between the Rating (1=low 6=high) in Least developed countries and Rating (1=low 6=high) in Low & middle income?
Provide a succinct answer. -0.12. In the year 2008, what is the difference between the Rating (1=low 6=high) in Least developed countries and Rating (1=low 6=high) in Gambia, The?
Keep it short and to the point. -0.07. In the year 2008, what is the difference between the Rating (1=low 6=high) of Least developed countries and Rating (1=low 6=high) of Nigeria?
Make the answer very short. -0.87. In the year 2008, what is the difference between the Rating (1=low 6=high) in Low & middle income and Rating (1=low 6=high) in Gambia, The?
Provide a short and direct response. 0.04. In the year 2008, what is the difference between the Rating (1=low 6=high) in Low & middle income and Rating (1=low 6=high) in Nigeria?
Your response must be concise. -0.76. In the year 2008, what is the difference between the Rating (1=low 6=high) in Gambia, The and Rating (1=low 6=high) in Nigeria?
Keep it short and to the point. -0.8. In the year 2009, what is the difference between the Rating (1=low 6=high) of Least developed countries and Rating (1=low 6=high) of Low & middle income?
Your answer should be compact. -0.12. In the year 2009, what is the difference between the Rating (1=low 6=high) of Least developed countries and Rating (1=low 6=high) of Gambia, The?
Keep it short and to the point. -0.09. In the year 2009, what is the difference between the Rating (1=low 6=high) in Least developed countries and Rating (1=low 6=high) in Nigeria?
Ensure brevity in your answer.  -0.92. In the year 2009, what is the difference between the Rating (1=low 6=high) in Low & middle income and Rating (1=low 6=high) in Gambia, The?
Provide a short and direct response. 0.04. In the year 2009, what is the difference between the Rating (1=low 6=high) in Low & middle income and Rating (1=low 6=high) in Nigeria?
Ensure brevity in your answer.  -0.79. In the year 2010, what is the difference between the Rating (1=low 6=high) in Least developed countries and Rating (1=low 6=high) in Low & middle income?
Give a very brief answer. -0.11. In the year 2010, what is the difference between the Rating (1=low 6=high) in Least developed countries and Rating (1=low 6=high) in Gambia, The?
Ensure brevity in your answer.  -0.09. In the year 2010, what is the difference between the Rating (1=low 6=high) of Least developed countries and Rating (1=low 6=high) of Nigeria?
Provide a succinct answer. -0.75. In the year 2010, what is the difference between the Rating (1=low 6=high) in Low & middle income and Rating (1=low 6=high) in Gambia, The?
Ensure brevity in your answer.  0.03. In the year 2010, what is the difference between the Rating (1=low 6=high) of Low & middle income and Rating (1=low 6=high) of Nigeria?
Ensure brevity in your answer.  -0.64. In the year 2010, what is the difference between the Rating (1=low 6=high) of Gambia, The and Rating (1=low 6=high) of Nigeria?
Ensure brevity in your answer.  -0.67. In the year 2011, what is the difference between the Rating (1=low 6=high) of Least developed countries and Rating (1=low 6=high) of Low & middle income?
Offer a very short reply. -0.09. In the year 2011, what is the difference between the Rating (1=low 6=high) of Least developed countries and Rating (1=low 6=high) of Gambia, The?
Make the answer very short. -0.09. In the year 2011, what is the difference between the Rating (1=low 6=high) of Least developed countries and Rating (1=low 6=high) of Nigeria?
Ensure brevity in your answer.  -0.59. In the year 2011, what is the difference between the Rating (1=low 6=high) of Low & middle income and Rating (1=low 6=high) of Gambia, The?
Offer a terse response. -0. In the year 2011, what is the difference between the Rating (1=low 6=high) in Low & middle income and Rating (1=low 6=high) in Nigeria?
Give a very brief answer. -0.5. In the year 2011, what is the difference between the Rating (1=low 6=high) in Gambia, The and Rating (1=low 6=high) in Nigeria?
Your response must be concise. -0.5. In the year 2012, what is the difference between the Rating (1=low 6=high) of Least developed countries and Rating (1=low 6=high) of Low & middle income?
Keep it short and to the point. -0.12. In the year 2012, what is the difference between the Rating (1=low 6=high) of Least developed countries and Rating (1=low 6=high) of Gambia, The?
Your answer should be very brief. -0.01. In the year 2012, what is the difference between the Rating (1=low 6=high) in Least developed countries and Rating (1=low 6=high) in Nigeria?
Your answer should be compact. -1.01. In the year 2012, what is the difference between the Rating (1=low 6=high) in Low & middle income and Rating (1=low 6=high) in Gambia, The?
Your answer should be very brief. 0.11. In the year 2012, what is the difference between the Rating (1=low 6=high) in Low & middle income and Rating (1=low 6=high) in Nigeria?
Your answer should be very brief. -0.89. In the year 2013, what is the difference between the Rating (1=low 6=high) of Least developed countries and Rating (1=low 6=high) of Low & middle income?
Provide a short and direct response. -0.11. In the year 2013, what is the difference between the Rating (1=low 6=high) in Least developed countries and Rating (1=low 6=high) in Gambia, The?
Make the answer very short. 0.3. In the year 2013, what is the difference between the Rating (1=low 6=high) in Least developed countries and Rating (1=low 6=high) in Nigeria?
Your answer should be compact. -1.2. In the year 2013, what is the difference between the Rating (1=low 6=high) of Low & middle income and Rating (1=low 6=high) of Gambia, The?
Provide a succinct answer. 0.41. In the year 2013, what is the difference between the Rating (1=low 6=high) of Low & middle income and Rating (1=low 6=high) of Nigeria?
Offer a very short reply. -1.09. In the year 2013, what is the difference between the Rating (1=low 6=high) in Gambia, The and Rating (1=low 6=high) in Nigeria?
Provide a succinct answer. -1.5. What is the ratio of the Rating (1=low 6=high) of Least developed countries in 2006 to that in 2007?
Give a very brief answer. 0.99. What is the ratio of the Rating (1=low 6=high) of Gambia, The in 2006 to that in 2007?
Offer a very short reply. 0.9. What is the ratio of the Rating (1=low 6=high) of Nigeria in 2006 to that in 2007?
Your response must be concise. 0.92. What is the ratio of the Rating (1=low 6=high) of Least developed countries in 2006 to that in 2008?
Keep it short and to the point. 0.98. What is the ratio of the Rating (1=low 6=high) in Low & middle income in 2006 to that in 2008?
Give a very brief answer. 1. What is the ratio of the Rating (1=low 6=high) in Nigeria in 2006 to that in 2008?
Your answer should be compact. 0.93. What is the ratio of the Rating (1=low 6=high) in Least developed countries in 2006 to that in 2009?
Your answer should be compact. 0.98. What is the ratio of the Rating (1=low 6=high) of Least developed countries in 2006 to that in 2010?
Make the answer very short. 0.98. What is the ratio of the Rating (1=low 6=high) of Low & middle income in 2006 to that in 2010?
Your answer should be very brief. 1.01. What is the ratio of the Rating (1=low 6=high) of Least developed countries in 2006 to that in 2011?
Your response must be concise. 0.99. What is the ratio of the Rating (1=low 6=high) in Low & middle income in 2006 to that in 2011?
Give a very brief answer. 1.01. What is the ratio of the Rating (1=low 6=high) in Low & middle income in 2006 to that in 2012?
Give a very brief answer. 1.03. What is the ratio of the Rating (1=low 6=high) of Least developed countries in 2006 to that in 2013?
Keep it short and to the point. 1.02. What is the ratio of the Rating (1=low 6=high) in Low & middle income in 2006 to that in 2013?
Your answer should be very brief. 1.04. What is the ratio of the Rating (1=low 6=high) of Gambia, The in 2006 to that in 2013?
Your response must be concise. 1. What is the ratio of the Rating (1=low 6=high) in Low & middle income in 2007 to that in 2008?
Your answer should be very brief. 1. What is the ratio of the Rating (1=low 6=high) in Gambia, The in 2007 to that in 2008?
Your answer should be compact. 0.95. What is the ratio of the Rating (1=low 6=high) of Least developed countries in 2007 to that in 2009?
Ensure brevity in your answer.  1. What is the ratio of the Rating (1=low 6=high) in Low & middle income in 2007 to that in 2009?
Keep it short and to the point. 1. What is the ratio of the Rating (1=low 6=high) in Gambia, The in 2007 to that in 2009?
Make the answer very short. 0.95. What is the ratio of the Rating (1=low 6=high) in Least developed countries in 2007 to that in 2010?
Your answer should be very brief. 1. What is the ratio of the Rating (1=low 6=high) of Low & middle income in 2007 to that in 2010?
Offer a terse response. 1.01. What is the ratio of the Rating (1=low 6=high) of Low & middle income in 2007 to that in 2011?
Give a very brief answer. 1.02. What is the ratio of the Rating (1=low 6=high) in Gambia, The in 2007 to that in 2011?
Keep it short and to the point. 0.95. What is the ratio of the Rating (1=low 6=high) in Least developed countries in 2007 to that in 2012?
Your answer should be compact. 1.02. What is the ratio of the Rating (1=low 6=high) of Low & middle income in 2007 to that in 2012?
Your answer should be very brief. 1.03. What is the ratio of the Rating (1=low 6=high) of Nigeria in 2007 to that in 2012?
Give a very brief answer. 1. What is the ratio of the Rating (1=low 6=high) of Least developed countries in 2007 to that in 2013?
Make the answer very short. 1.03. What is the ratio of the Rating (1=low 6=high) of Low & middle income in 2007 to that in 2013?
Offer a very short reply. 1.04. What is the ratio of the Rating (1=low 6=high) of Least developed countries in 2008 to that in 2009?
Ensure brevity in your answer.  1. What is the ratio of the Rating (1=low 6=high) in Low & middle income in 2008 to that in 2009?
Offer a terse response. 1. What is the ratio of the Rating (1=low 6=high) of Gambia, The in 2008 to that in 2009?
Provide a short and direct response. 1. What is the ratio of the Rating (1=low 6=high) in Nigeria in 2008 to that in 2010?
Make the answer very short. 1.03. What is the ratio of the Rating (1=low 6=high) in Least developed countries in 2008 to that in 2011?
Your answer should be very brief. 1.01. What is the ratio of the Rating (1=low 6=high) in Low & middle income in 2008 to that in 2011?
Offer a terse response. 1.01. What is the ratio of the Rating (1=low 6=high) of Nigeria in 2008 to that in 2011?
Offer a terse response. 1.07. What is the ratio of the Rating (1=low 6=high) in Least developed countries in 2008 to that in 2012?
Ensure brevity in your answer.  1.03. What is the ratio of the Rating (1=low 6=high) in Low & middle income in 2008 to that in 2012?
Ensure brevity in your answer.  1.03. What is the ratio of the Rating (1=low 6=high) in Gambia, The in 2008 to that in 2012?
Your answer should be very brief. 1.05. What is the ratio of the Rating (1=low 6=high) in Nigeria in 2008 to that in 2012?
Give a very brief answer. 0.99. What is the ratio of the Rating (1=low 6=high) of Least developed countries in 2008 to that in 2013?
Keep it short and to the point. 1.04. What is the ratio of the Rating (1=low 6=high) in Low & middle income in 2008 to that in 2013?
Ensure brevity in your answer.  1.04. What is the ratio of the Rating (1=low 6=high) in Nigeria in 2008 to that in 2013?
Provide a short and direct response. 0.96. What is the ratio of the Rating (1=low 6=high) of Gambia, The in 2009 to that in 2010?
Make the answer very short. 1. What is the ratio of the Rating (1=low 6=high) of Nigeria in 2009 to that in 2010?
Offer a very short reply. 1.04. What is the ratio of the Rating (1=low 6=high) of Low & middle income in 2009 to that in 2011?
Make the answer very short. 1.01. What is the ratio of the Rating (1=low 6=high) of Gambia, The in 2009 to that in 2011?
Provide a succinct answer. 1. What is the ratio of the Rating (1=low 6=high) in Nigeria in 2009 to that in 2011?
Provide a succinct answer. 1.08. What is the ratio of the Rating (1=low 6=high) in Least developed countries in 2009 to that in 2012?
Make the answer very short. 1.03. What is the ratio of the Rating (1=low 6=high) in Low & middle income in 2009 to that in 2012?
Make the answer very short. 1.03. What is the ratio of the Rating (1=low 6=high) in Gambia, The in 2009 to that in 2012?
Your answer should be compact. 1.05. What is the ratio of the Rating (1=low 6=high) in Least developed countries in 2009 to that in 2013?
Ensure brevity in your answer.  1.03. What is the ratio of the Rating (1=low 6=high) in Low & middle income in 2009 to that in 2013?
Ensure brevity in your answer.  1.04. What is the ratio of the Rating (1=low 6=high) of Gambia, The in 2009 to that in 2013?
Ensure brevity in your answer.  1.17. What is the ratio of the Rating (1=low 6=high) in Nigeria in 2009 to that in 2013?
Offer a very short reply. 0.96. What is the ratio of the Rating (1=low 6=high) of Least developed countries in 2010 to that in 2011?
Your answer should be compact. 1. What is the ratio of the Rating (1=low 6=high) of Low & middle income in 2010 to that in 2011?
Make the answer very short. 1.01. What is the ratio of the Rating (1=low 6=high) of Nigeria in 2010 to that in 2011?
Ensure brevity in your answer.  1.04. What is the ratio of the Rating (1=low 6=high) in Least developed countries in 2010 to that in 2012?
Make the answer very short. 1.03. What is the ratio of the Rating (1=low 6=high) of Low & middle income in 2010 to that in 2012?
Make the answer very short. 1.02. What is the ratio of the Rating (1=low 6=high) of Gambia, The in 2010 to that in 2012?
Provide a succinct answer. 1.05. What is the ratio of the Rating (1=low 6=high) of Nigeria in 2010 to that in 2012?
Make the answer very short. 0.96. What is the ratio of the Rating (1=low 6=high) of Least developed countries in 2010 to that in 2013?
Give a very brief answer. 1.03. What is the ratio of the Rating (1=low 6=high) of Low & middle income in 2010 to that in 2013?
Your response must be concise. 1.03. What is the ratio of the Rating (1=low 6=high) of Gambia, The in 2010 to that in 2013?
Your answer should be compact. 1.17. What is the ratio of the Rating (1=low 6=high) in Nigeria in 2010 to that in 2013?
Your response must be concise. 0.93. What is the ratio of the Rating (1=low 6=high) of Least developed countries in 2011 to that in 2012?
Make the answer very short. 1.02. What is the ratio of the Rating (1=low 6=high) in Low & middle income in 2011 to that in 2012?
Keep it short and to the point. 1.01. What is the ratio of the Rating (1=low 6=high) of Least developed countries in 2011 to that in 2013?
Ensure brevity in your answer.  1.03. What is the ratio of the Rating (1=low 6=high) in Low & middle income in 2011 to that in 2013?
Provide a succinct answer. 1.02. What is the ratio of the Rating (1=low 6=high) in Gambia, The in 2011 to that in 2013?
Provide a short and direct response. 1.17. What is the ratio of the Rating (1=low 6=high) of Least developed countries in 2012 to that in 2013?
Your answer should be very brief. 1.01. What is the ratio of the Rating (1=low 6=high) of Gambia, The in 2012 to that in 2013?
Ensure brevity in your answer.  1.11. What is the ratio of the Rating (1=low 6=high) in Nigeria in 2012 to that in 2013?
Your answer should be compact. 0.96. What is the difference between the highest and the second highest Rating (1=low 6=high) of Least developed countries?
Provide a succinct answer. 0.01. What is the difference between the highest and the second highest Rating (1=low 6=high) in Low & middle income?
Make the answer very short. 0. What is the difference between the highest and the second highest Rating (1=low 6=high) in Nigeria?
Offer a very short reply. 0.17. What is the difference between the highest and the lowest Rating (1=low 6=high) of Least developed countries?
Make the answer very short. 0.13. What is the difference between the highest and the lowest Rating (1=low 6=high) in Low & middle income?
Your answer should be compact. 0.14. What is the difference between the highest and the lowest Rating (1=low 6=high) of Nigeria?
Ensure brevity in your answer.  0.5. 